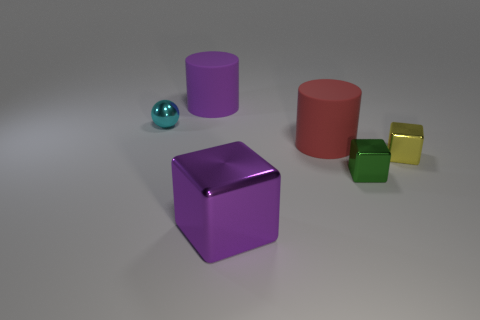Are there any gray matte cylinders that have the same size as the purple cube?
Offer a terse response. No. There is a cyan sphere that is the same size as the green cube; what is its material?
Offer a very short reply. Metal. What size is the thing that is left of the purple thing behind the purple shiny cube?
Provide a succinct answer. Small. There is a matte object in front of the purple rubber cylinder; is its size the same as the tiny green cube?
Make the answer very short. No. Are there more big red cylinders that are to the left of the red thing than large red rubber cylinders that are in front of the yellow block?
Offer a terse response. No. There is a small metal thing that is both behind the tiny green cube and on the right side of the large red matte object; what is its shape?
Offer a terse response. Cube. The tiny metallic thing in front of the tiny yellow shiny cube has what shape?
Make the answer very short. Cube. There is a matte thing that is behind the big cylinder to the right of the large purple object in front of the small green object; what is its size?
Your response must be concise. Large. Does the tiny cyan thing have the same shape as the big red matte thing?
Your answer should be compact. No. There is a shiny cube that is both behind the big purple block and to the left of the yellow shiny object; what size is it?
Provide a short and direct response. Small. 